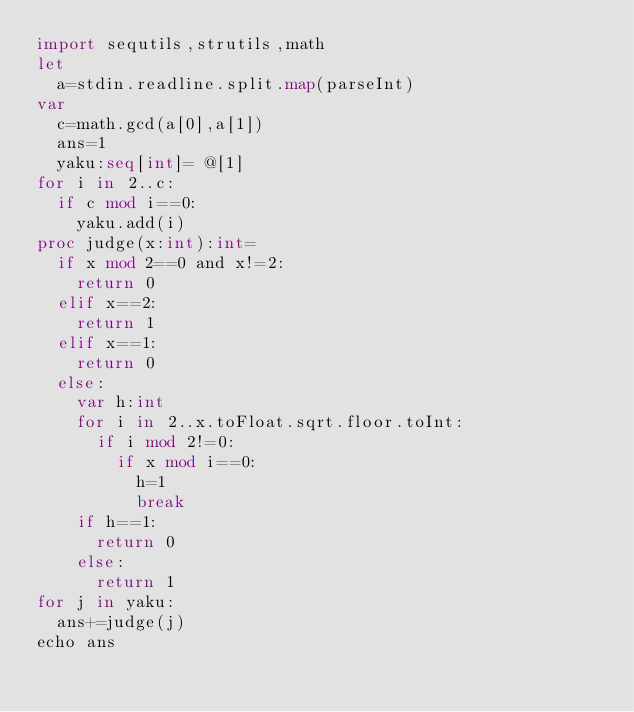Convert code to text. <code><loc_0><loc_0><loc_500><loc_500><_Nim_>import sequtils,strutils,math
let
  a=stdin.readline.split.map(parseInt)
var
  c=math.gcd(a[0],a[1])
  ans=1
  yaku:seq[int]= @[1]
for i in 2..c:
  if c mod i==0:
    yaku.add(i)
proc judge(x:int):int=
  if x mod 2==0 and x!=2:
    return 0
  elif x==2:
    return 1
  elif x==1:
    return 0
  else:
    var h:int
    for i in 2..x.toFloat.sqrt.floor.toInt:
      if i mod 2!=0:
        if x mod i==0:
          h=1
          break
    if h==1:
      return 0
    else:
      return 1
for j in yaku:
  ans+=judge(j)
echo ans</code> 